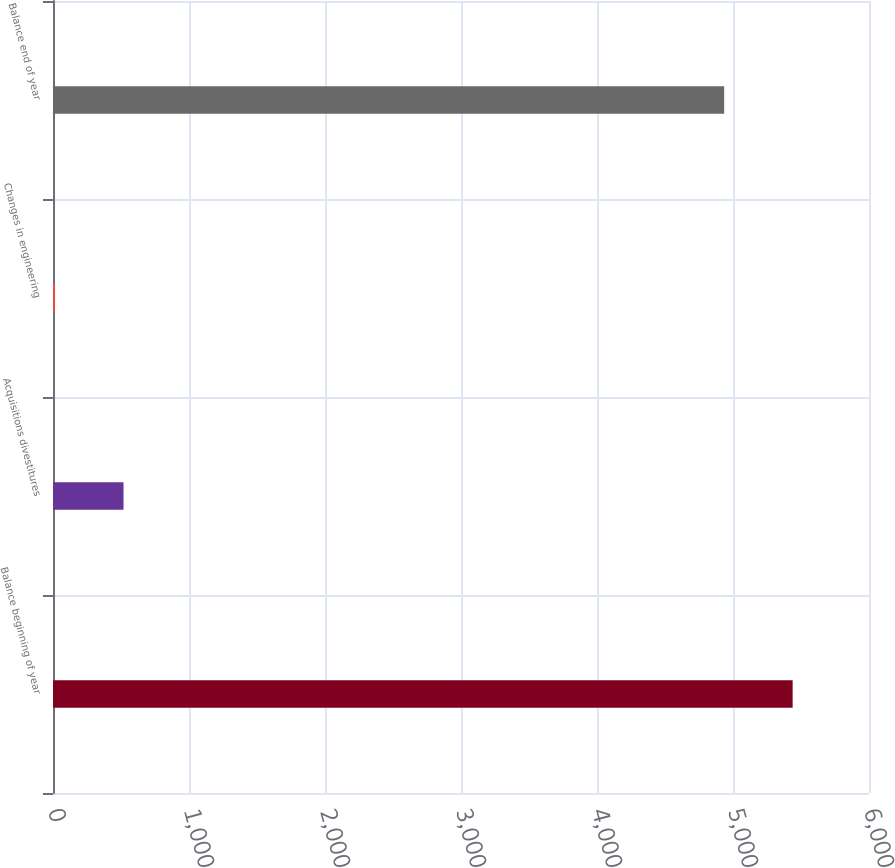Convert chart to OTSL. <chart><loc_0><loc_0><loc_500><loc_500><bar_chart><fcel>Balance beginning of year<fcel>Acquisitions divestitures<fcel>Changes in engineering<fcel>Balance end of year<nl><fcel>5438.6<fcel>518.6<fcel>15<fcel>4935<nl></chart> 